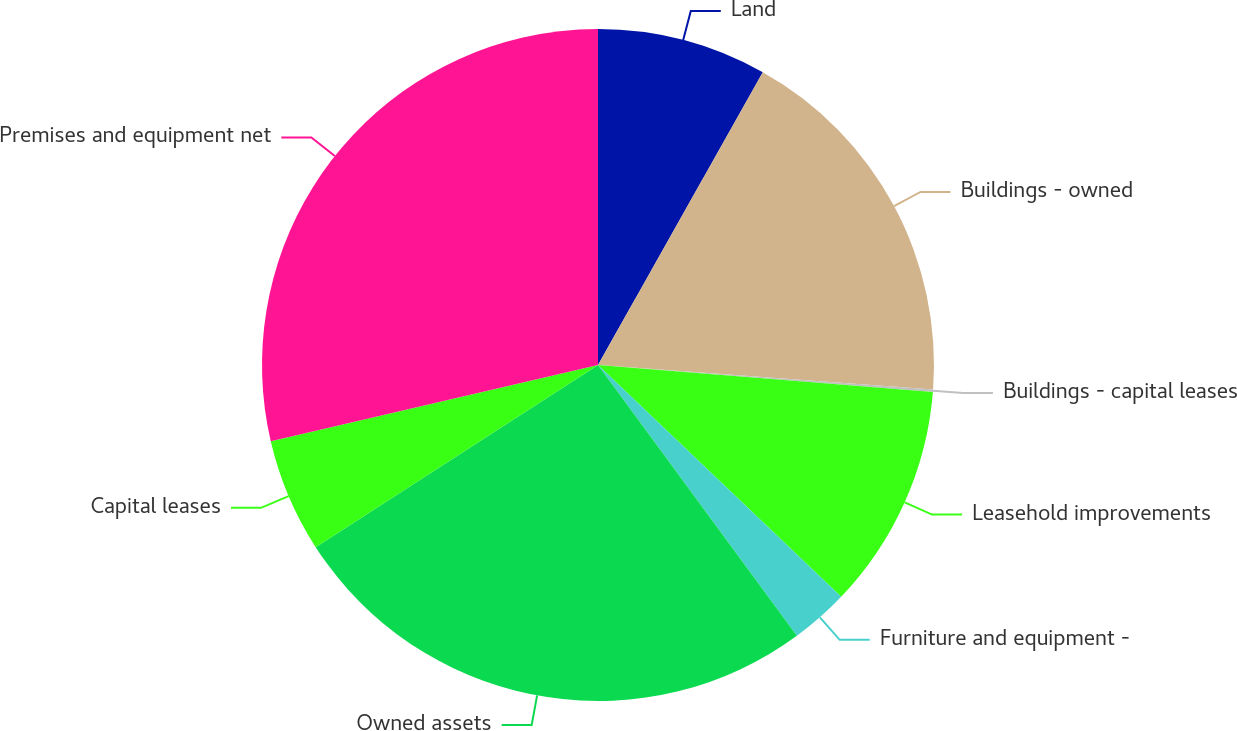Convert chart to OTSL. <chart><loc_0><loc_0><loc_500><loc_500><pie_chart><fcel>Land<fcel>Buildings - owned<fcel>Buildings - capital leases<fcel>Leasehold improvements<fcel>Furniture and equipment -<fcel>Owned assets<fcel>Capital leases<fcel>Premises and equipment net<nl><fcel>8.16%<fcel>18.0%<fcel>0.12%<fcel>10.84%<fcel>2.8%<fcel>25.96%<fcel>5.48%<fcel>28.64%<nl></chart> 